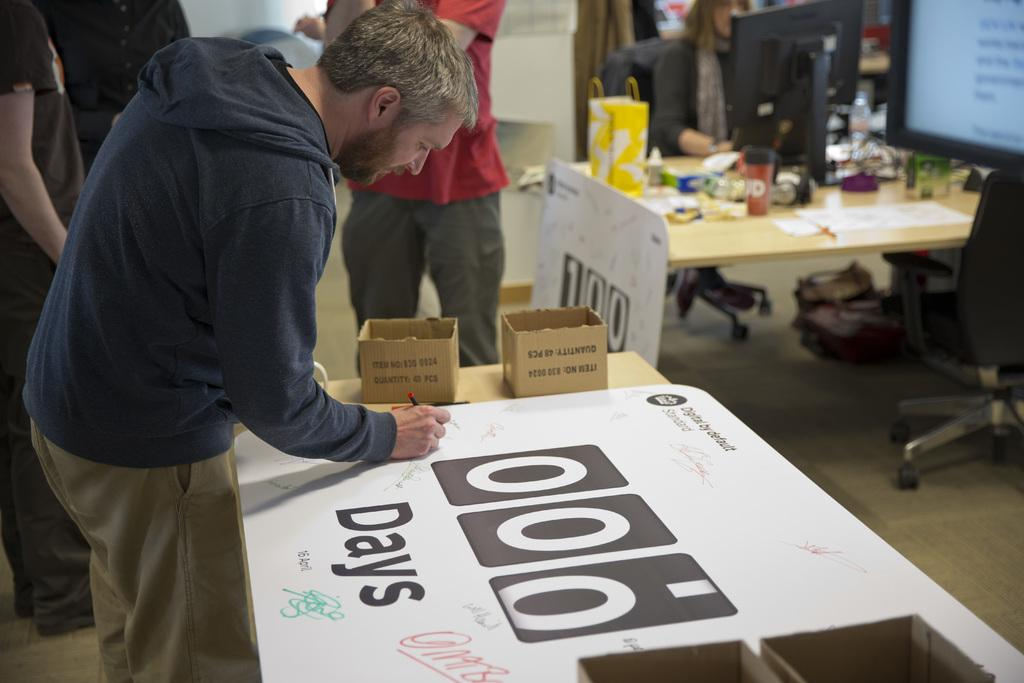How many people are in the image? There are persons standing in the image. What surface are the persons standing on? The persons are standing on the floor. What furniture is present in the image? There is a table and a chair in the image. What objects are on the table? There are boxes on the table. What electronic device is in the image? There is a screen in the image. Can you see a comb being used on the chicken in the image? There is no chicken or comb present in the image. What type of sponge is being used to clean the screen in the image? There is no sponge visible in the image, and the screen is not being cleaned. 